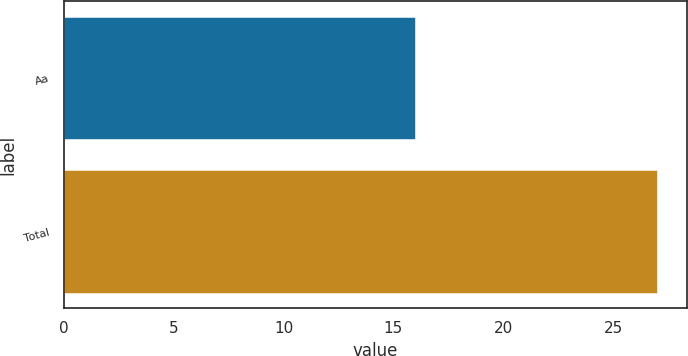<chart> <loc_0><loc_0><loc_500><loc_500><bar_chart><fcel>Aa<fcel>Total<nl><fcel>16<fcel>27<nl></chart> 